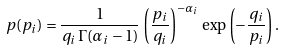<formula> <loc_0><loc_0><loc_500><loc_500>\ p ( p _ { i } ) = \frac { 1 } { q _ { i } \, \Gamma ( \alpha _ { i } - 1 ) } \, \left ( \frac { p _ { i } } { q _ { i } } \right ) ^ { - \alpha _ { i } } \, \exp \left ( - \frac { q _ { i } } { p _ { i } } \right ) .</formula> 